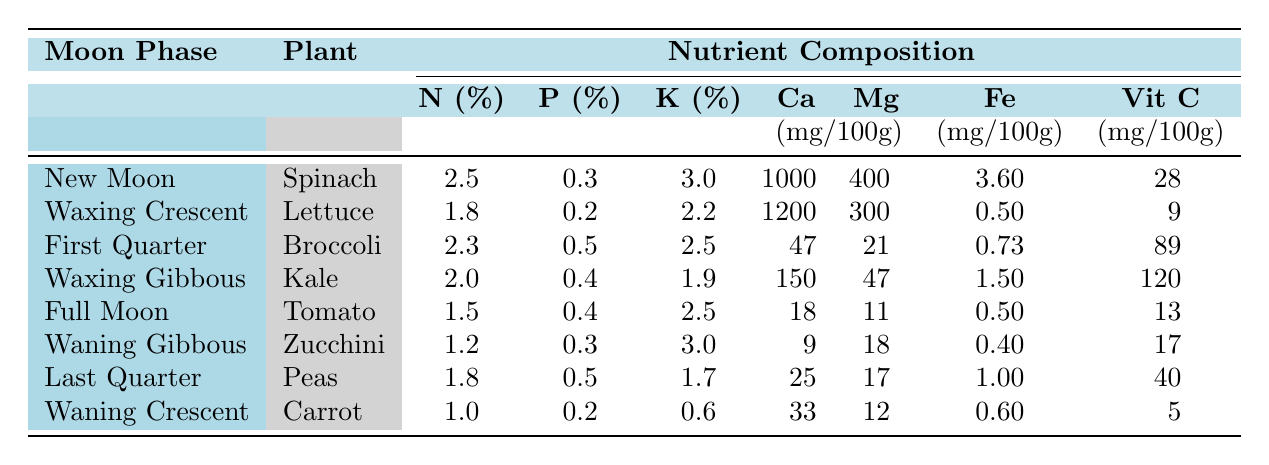What is the nutrient composition of Spinach harvested during the New Moon phase? The table indicates that Spinach harvested during the New Moon phase has the following nutrient composition: Nitrogen (N) is 2.5%, Phosphorus (P) is 0.3%, Potassium (K) is 3.0%, Calcium (Ca) is 1000 mg/100g, Magnesium (Mg) is 400 mg/100g, Iron (Fe) is 3.60 mg/100g, and Vitamin C is 28 mg/100g.
Answer: 2.5% N, 0.3% P, 3.0% K, 1000 mg Ca, 400 mg Mg, 3.60 mg Fe, 28 mg Vit C Which plant has the highest Calcium content and during which moon phase was it harvested? Reviewing the table, Kale has the highest Calcium content of 150 mg/100g, harvested during the Waxing Gibbous phase.
Answer: Kale during Waxing Gibbous How does the Potassium content of Zucchini compare to that of the Lettuce? From the table, Zucchini has a Potassium content of 3.0%, while Lettuce has 2.2%. To compare, Zucchini has 0.8% more Potassium than Lettuce.
Answer: Zucchini has 0.8% more K than Lettuce Is the Iron content of Peas higher than that of Carrot? The Iron content of Peas is 1.0 mg/100g and that of Carrot is 0.6 mg/100g. Since 1.0 mg/100g is greater than 0.6 mg/100g, this statement is true.
Answer: Yes What is the average Vitamin C content of the plants harvested from the New Moon to the Full Moon phases? The Vitamin C contents for these phases are: Spinach (28 mg/100g), Lettuce (9 mg/100g), Broccoli (89 mg/100g), Kale (120 mg/100g), and Tomato (13 mg/100g). Adding these gives: 28 + 9 + 89 + 120 + 13 = 259 mg/100g. Dividing by 5 provides the average: 259/5 = 51.8 mg/100g.
Answer: 51.8 mg/100g Which moon phase corresponds to the plant that has the lowest Nitrogen content? Looking at the Nitrogen content in the table, Carrot has the lowest at 1.0%, which was harvested during the Waning Crescent phase.
Answer: Waning Crescent 